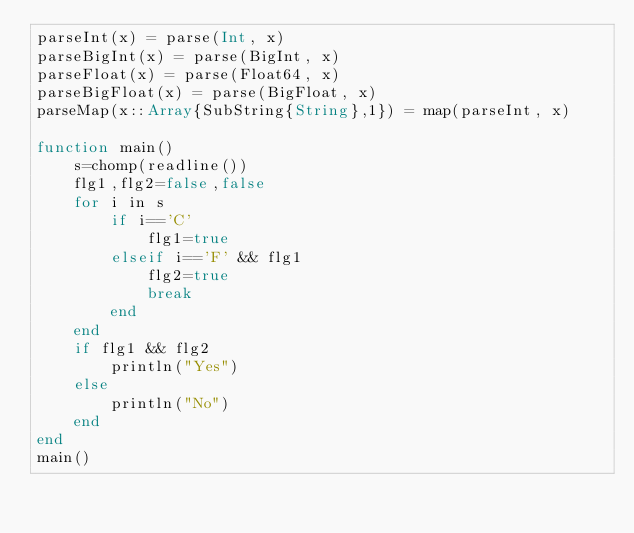Convert code to text. <code><loc_0><loc_0><loc_500><loc_500><_Julia_>parseInt(x) = parse(Int, x)
parseBigInt(x) = parse(BigInt, x)
parseFloat(x) = parse(Float64, x)
parseBigFloat(x) = parse(BigFloat, x)
parseMap(x::Array{SubString{String},1}) = map(parseInt, x)

function main()
    s=chomp(readline())
    flg1,flg2=false,false
    for i in s
        if i=='C'
            flg1=true
        elseif i=='F' && flg1
            flg2=true
            break
        end
    end
    if flg1 && flg2
        println("Yes")
    else
        println("No")
    end
end
main()</code> 